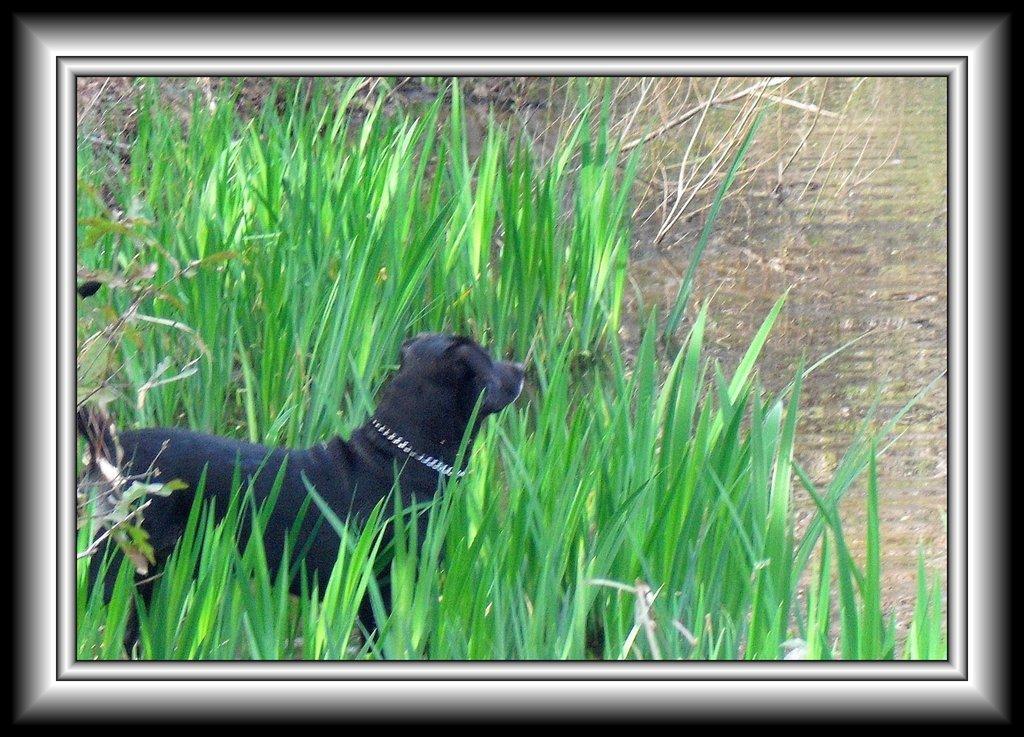Please provide a concise description of this image. As we can see in the image there is a black color dog and grass. 